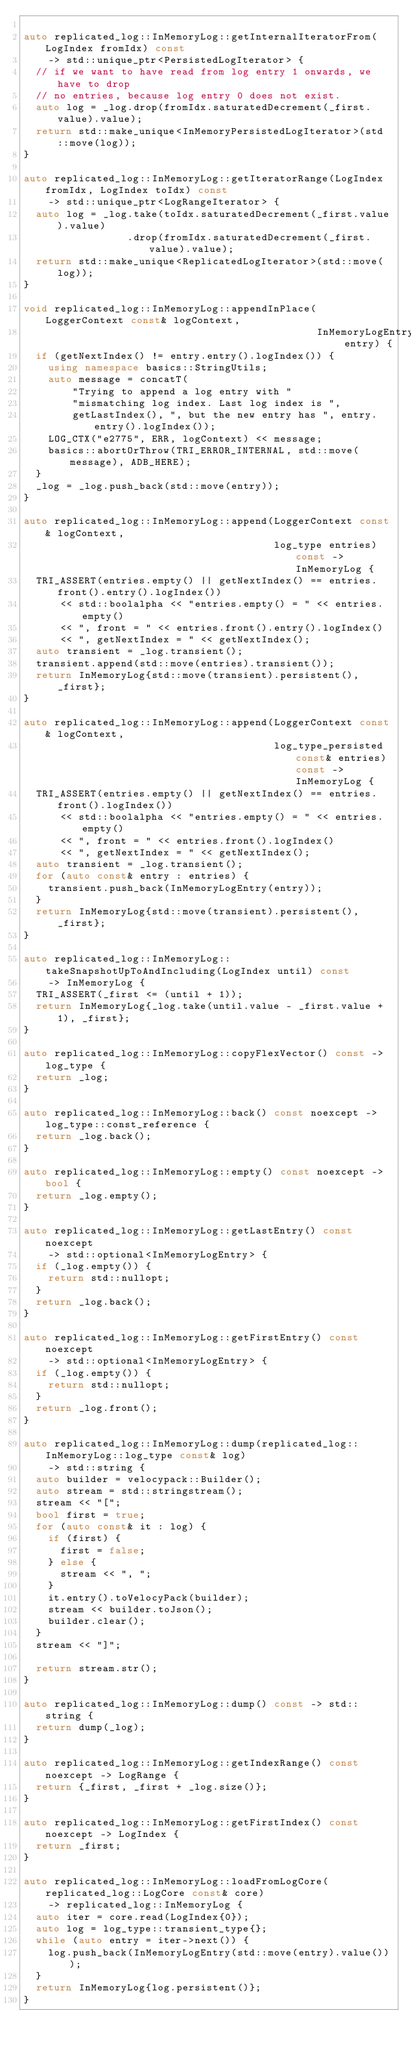<code> <loc_0><loc_0><loc_500><loc_500><_C++_>
auto replicated_log::InMemoryLog::getInternalIteratorFrom(LogIndex fromIdx) const
    -> std::unique_ptr<PersistedLogIterator> {
  // if we want to have read from log entry 1 onwards, we have to drop
  // no entries, because log entry 0 does not exist.
  auto log = _log.drop(fromIdx.saturatedDecrement(_first.value).value);
  return std::make_unique<InMemoryPersistedLogIterator>(std::move(log));
}

auto replicated_log::InMemoryLog::getIteratorRange(LogIndex fromIdx, LogIndex toIdx) const
    -> std::unique_ptr<LogRangeIterator> {
  auto log = _log.take(toIdx.saturatedDecrement(_first.value).value)
                 .drop(fromIdx.saturatedDecrement(_first.value).value);
  return std::make_unique<ReplicatedLogIterator>(std::move(log));
}

void replicated_log::InMemoryLog::appendInPlace(LoggerContext const& logContext,
                                                InMemoryLogEntry entry) {
  if (getNextIndex() != entry.entry().logIndex()) {
    using namespace basics::StringUtils;
    auto message = concatT(
        "Trying to append a log entry with "
        "mismatching log index. Last log index is ",
        getLastIndex(), ", but the new entry has ", entry.entry().logIndex());
    LOG_CTX("e2775", ERR, logContext) << message;
    basics::abortOrThrow(TRI_ERROR_INTERNAL, std::move(message), ADB_HERE);
  }
  _log = _log.push_back(std::move(entry));
}

auto replicated_log::InMemoryLog::append(LoggerContext const& logContext,
                                         log_type entries) const -> InMemoryLog {
  TRI_ASSERT(entries.empty() || getNextIndex() == entries.front().entry().logIndex())
      << std::boolalpha << "entries.empty() = " << entries.empty()
      << ", front = " << entries.front().entry().logIndex()
      << ", getNextIndex = " << getNextIndex();
  auto transient = _log.transient();
  transient.append(std::move(entries).transient());
  return InMemoryLog{std::move(transient).persistent(), _first};
}

auto replicated_log::InMemoryLog::append(LoggerContext const& logContext,
                                         log_type_persisted const& entries) const -> InMemoryLog {
  TRI_ASSERT(entries.empty() || getNextIndex() == entries.front().logIndex())
      << std::boolalpha << "entries.empty() = " << entries.empty()
      << ", front = " << entries.front().logIndex()
      << ", getNextIndex = " << getNextIndex();
  auto transient = _log.transient();
  for (auto const& entry : entries) {
    transient.push_back(InMemoryLogEntry(entry));
  }
  return InMemoryLog{std::move(transient).persistent(), _first};
}

auto replicated_log::InMemoryLog::takeSnapshotUpToAndIncluding(LogIndex until) const
    -> InMemoryLog {
  TRI_ASSERT(_first <= (until + 1));
  return InMemoryLog{_log.take(until.value - _first.value + 1), _first};
}

auto replicated_log::InMemoryLog::copyFlexVector() const -> log_type {
  return _log;
}

auto replicated_log::InMemoryLog::back() const noexcept -> log_type::const_reference {
  return _log.back();
}

auto replicated_log::InMemoryLog::empty() const noexcept -> bool {
  return _log.empty();
}

auto replicated_log::InMemoryLog::getLastEntry() const noexcept
    -> std::optional<InMemoryLogEntry> {
  if (_log.empty()) {
    return std::nullopt;
  }
  return _log.back();
}

auto replicated_log::InMemoryLog::getFirstEntry() const noexcept
    -> std::optional<InMemoryLogEntry> {
  if (_log.empty()) {
    return std::nullopt;
  }
  return _log.front();
}

auto replicated_log::InMemoryLog::dump(replicated_log::InMemoryLog::log_type const& log)
    -> std::string {
  auto builder = velocypack::Builder();
  auto stream = std::stringstream();
  stream << "[";
  bool first = true;
  for (auto const& it : log) {
    if (first) {
      first = false;
    } else {
      stream << ", ";
    }
    it.entry().toVelocyPack(builder);
    stream << builder.toJson();
    builder.clear();
  }
  stream << "]";

  return stream.str();
}

auto replicated_log::InMemoryLog::dump() const -> std::string {
  return dump(_log);
}

auto replicated_log::InMemoryLog::getIndexRange() const noexcept -> LogRange {
  return {_first, _first + _log.size()};
}

auto replicated_log::InMemoryLog::getFirstIndex() const noexcept -> LogIndex {
  return _first;
}

auto replicated_log::InMemoryLog::loadFromLogCore(replicated_log::LogCore const& core)
    -> replicated_log::InMemoryLog {
  auto iter = core.read(LogIndex{0});
  auto log = log_type::transient_type{};
  while (auto entry = iter->next()) {
    log.push_back(InMemoryLogEntry(std::move(entry).value()));
  }
  return InMemoryLog{log.persistent()};
}
</code> 